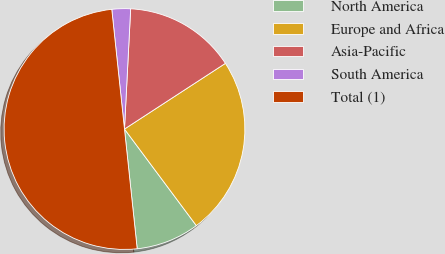Convert chart. <chart><loc_0><loc_0><loc_500><loc_500><pie_chart><fcel>North America<fcel>Europe and Africa<fcel>Asia-Pacific<fcel>South America<fcel>Total (1)<nl><fcel>8.5%<fcel>24.0%<fcel>15.0%<fcel>2.5%<fcel>50.0%<nl></chart> 